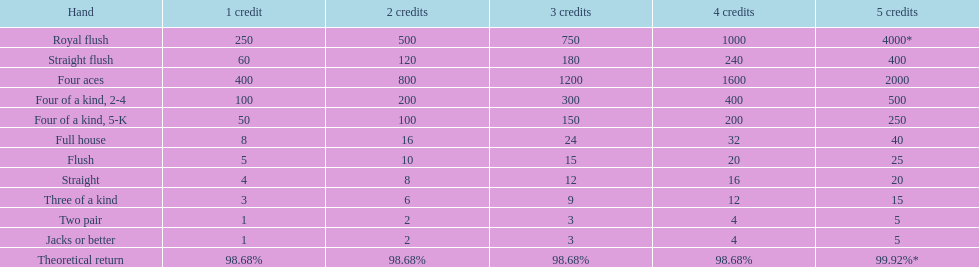Parse the full table. {'header': ['Hand', '1 credit', '2 credits', '3 credits', '4 credits', '5 credits'], 'rows': [['Royal flush', '250', '500', '750', '1000', '4000*'], ['Straight flush', '60', '120', '180', '240', '400'], ['Four aces', '400', '800', '1200', '1600', '2000'], ['Four of a kind, 2-4', '100', '200', '300', '400', '500'], ['Four of a kind, 5-K', '50', '100', '150', '200', '250'], ['Full house', '8', '16', '24', '32', '40'], ['Flush', '5', '10', '15', '20', '25'], ['Straight', '4', '8', '12', '16', '20'], ['Three of a kind', '3', '6', '9', '12', '15'], ['Two pair', '1', '2', '3', '4', '5'], ['Jacks or better', '1', '2', '3', '4', '5'], ['Theoretical return', '98.68%', '98.68%', '98.68%', '98.68%', '99.92%*']]} What is the complete value of a 3 credit straight flush? 180. 